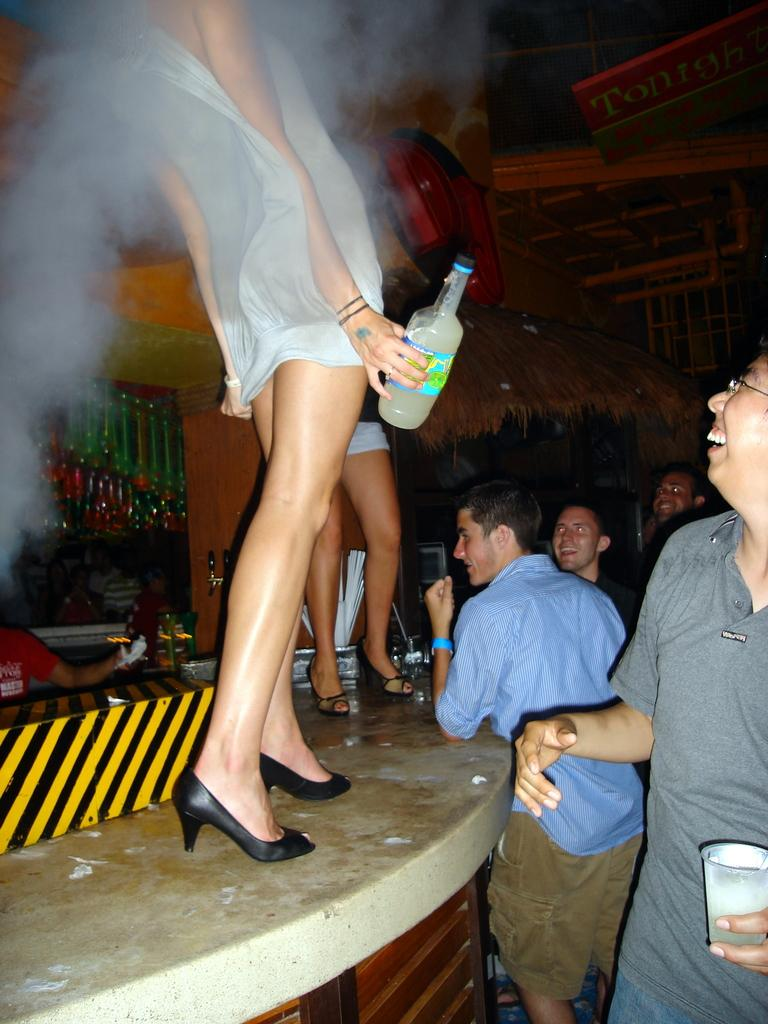How many women are in the image? There are two women in the image. What are the women doing in the image? The women are standing on a stepped surface. Are there any other people in the image besides the women? Yes, there are men standing on the right side of the image. What type of mint is growing on the stepped surface in the image? There is no mint visible in the image; the focus is on the women and men standing on the stepped surface. 